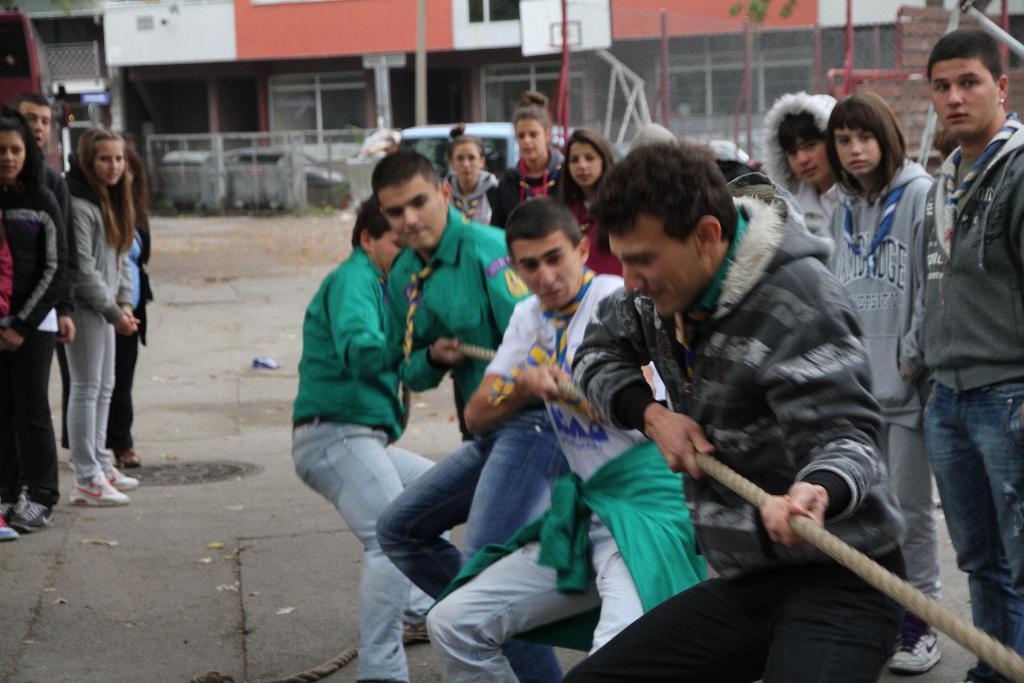How would you summarize this image in a sentence or two? In this image I can see group of people. In front the person is wearing gray and black color dress and the person is holding the rope. Background I can see few poles, the building is in white and peach color and I can see few plants in green color. 